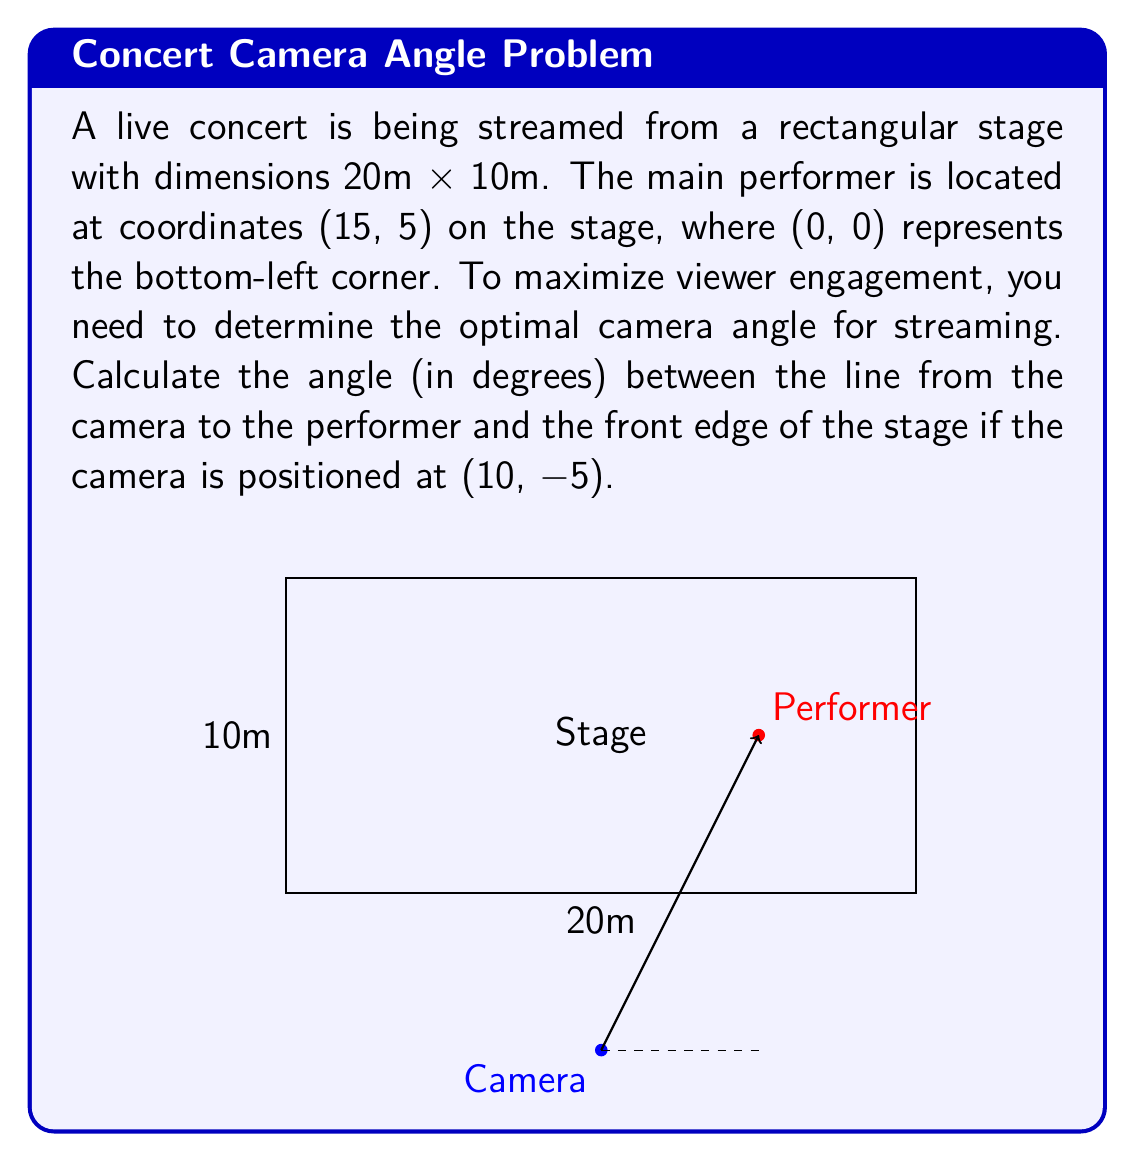Could you help me with this problem? To solve this problem, we'll follow these steps:

1) First, let's identify the two vectors we need:
   - Vector from camera to performer: $\vec{v} = (15-10, 5-(-5)) = (5, 10)$
   - Vector along the front edge of the stage: $\vec{u} = (20, 0) - (0, 0) = (20, 0)$

2) The angle between these vectors can be calculated using the dot product formula:

   $$\cos \theta = \frac{\vec{u} \cdot \vec{v}}{|\vec{u}||\vec{v}|}$$

3) Let's calculate each component:
   - $\vec{u} \cdot \vec{v} = 5 \cdot 20 + 10 \cdot 0 = 100$
   - $|\vec{u}| = \sqrt{20^2 + 0^2} = 20$
   - $|\vec{v}| = \sqrt{5^2 + 10^2} = \sqrt{125} = 5\sqrt{5}$

4) Substituting into the formula:

   $$\cos \theta = \frac{100}{20 \cdot 5\sqrt{5}} = \frac{1}{\sqrt{5}}$$

5) To get the angle, we need to take the inverse cosine (arccos):

   $$\theta = \arccos(\frac{1}{\sqrt{5}})$$

6) Converting to degrees:

   $$\theta = \arccos(\frac{1}{\sqrt{5}}) \cdot \frac{180}{\pi}$$
Answer: The optimal viewing angle is approximately 63.4°. 